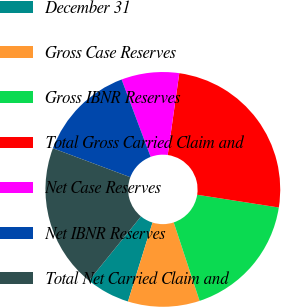<chart> <loc_0><loc_0><loc_500><loc_500><pie_chart><fcel>December 31<fcel>Gross Case Reserves<fcel>Gross IBNR Reserves<fcel>Total Gross Carried Claim and<fcel>Net Case Reserves<fcel>Net IBNR Reserves<fcel>Total Net Carried Claim and<nl><fcel>6.03%<fcel>9.87%<fcel>17.47%<fcel>25.23%<fcel>7.95%<fcel>13.59%<fcel>19.87%<nl></chart> 